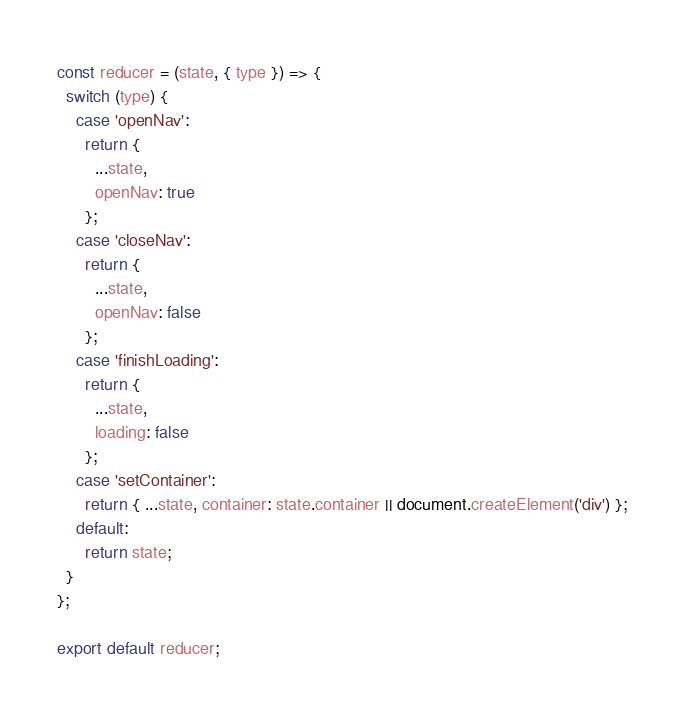Convert code to text. <code><loc_0><loc_0><loc_500><loc_500><_JavaScript_>const reducer = (state, { type }) => {
  switch (type) {
    case 'openNav':
      return {
        ...state,
        openNav: true
      };
    case 'closeNav':
      return {
        ...state,
        openNav: false
      };
    case 'finishLoading':
      return {
        ...state,
        loading: false
      };
    case 'setContainer':
      return { ...state, container: state.container || document.createElement('div') };
    default:
      return state;
  }
};

export default reducer;
</code> 